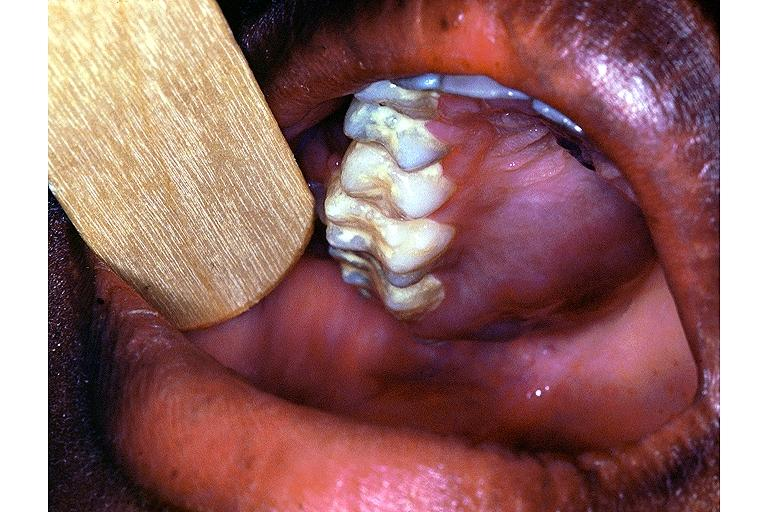does this image show burkit lymphoma?
Answer the question using a single word or phrase. Yes 